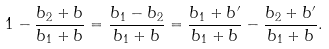Convert formula to latex. <formula><loc_0><loc_0><loc_500><loc_500>1 - \frac { b _ { 2 } + b } { b _ { 1 } + b } = \frac { b _ { 1 } - b _ { 2 } } { b _ { 1 } + b } = \frac { b _ { 1 } + b ^ { \prime } } { b _ { 1 } + b } - \frac { b _ { 2 } + b ^ { \prime } } { b _ { 1 } + b } .</formula> 